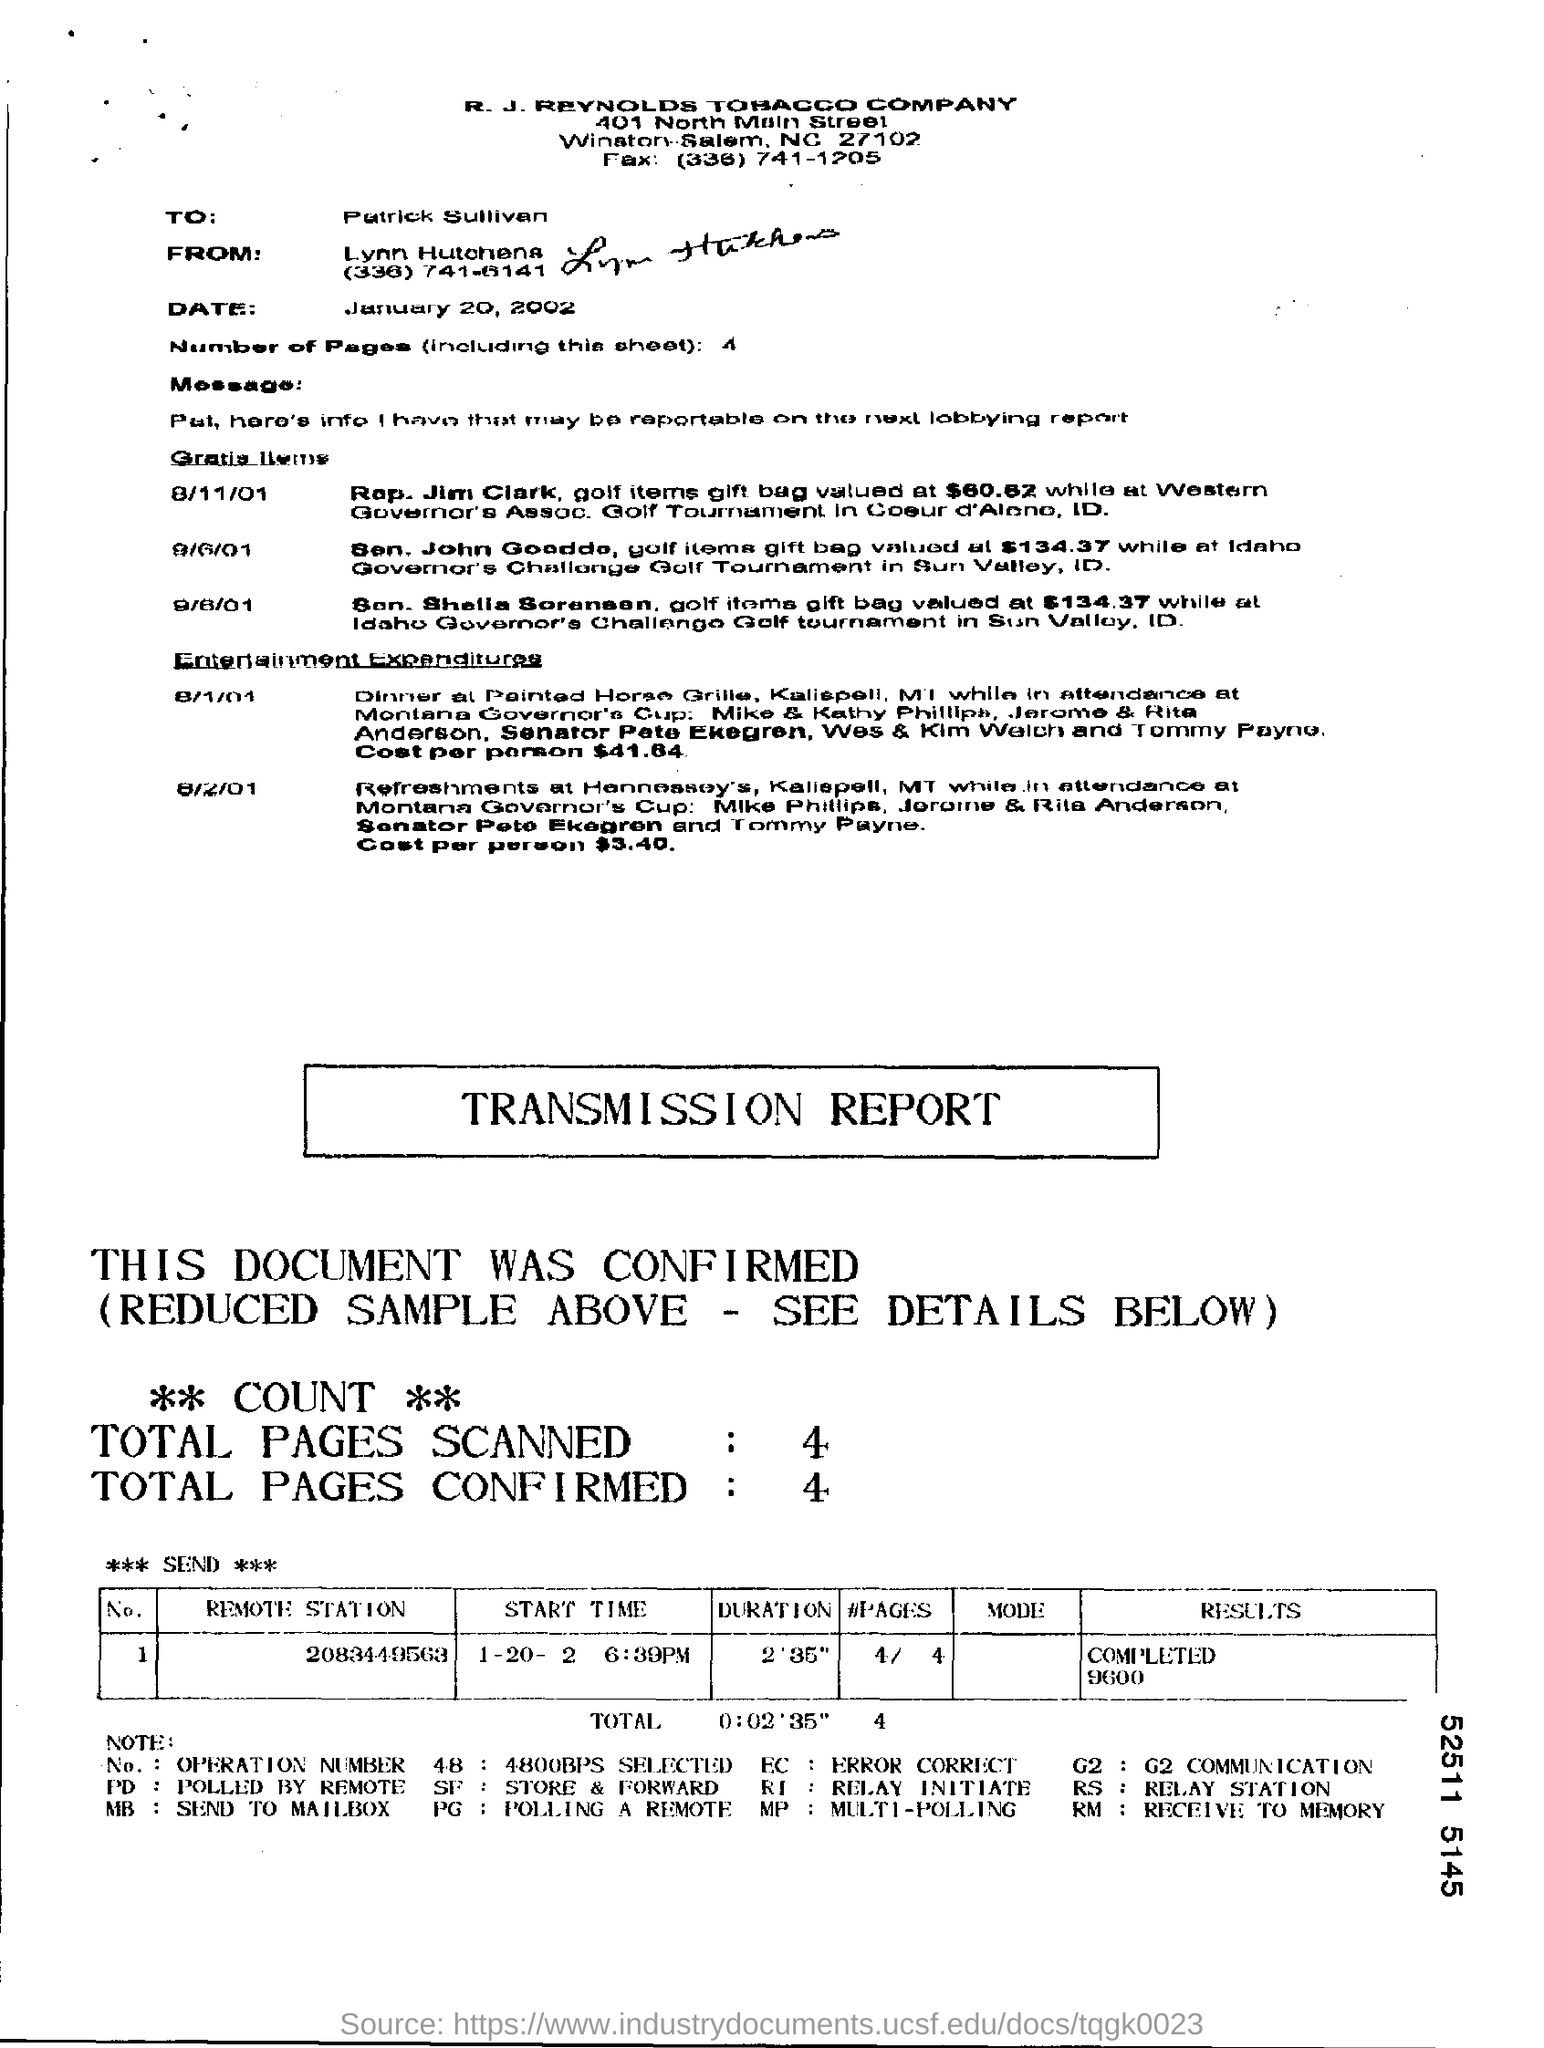Specify some key components in this picture. In total, 4 pages were scanned. The subject of the message is unclear. It is possible that "Patrick Sullivan" is the recipient, but this is not certain. There are four pages in the fax, including the cover sheet. There are a total of 4 pages in the document, including this sheet. R.J Reynolds Tobacco Company is located in the state of North Carolina, which is abbreviated as NC. 